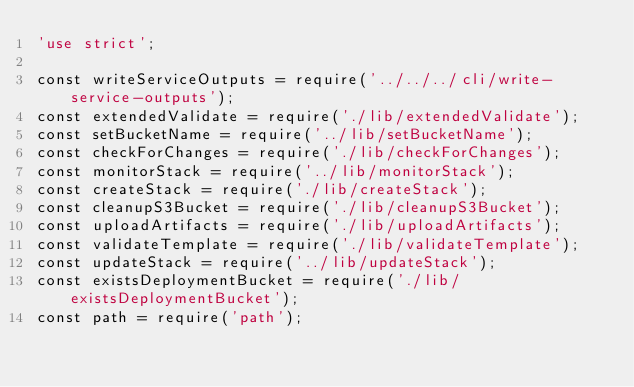Convert code to text. <code><loc_0><loc_0><loc_500><loc_500><_JavaScript_>'use strict';

const writeServiceOutputs = require('../../../cli/write-service-outputs');
const extendedValidate = require('./lib/extendedValidate');
const setBucketName = require('../lib/setBucketName');
const checkForChanges = require('./lib/checkForChanges');
const monitorStack = require('../lib/monitorStack');
const createStack = require('./lib/createStack');
const cleanupS3Bucket = require('./lib/cleanupS3Bucket');
const uploadArtifacts = require('./lib/uploadArtifacts');
const validateTemplate = require('./lib/validateTemplate');
const updateStack = require('../lib/updateStack');
const existsDeploymentBucket = require('./lib/existsDeploymentBucket');
const path = require('path');</code> 